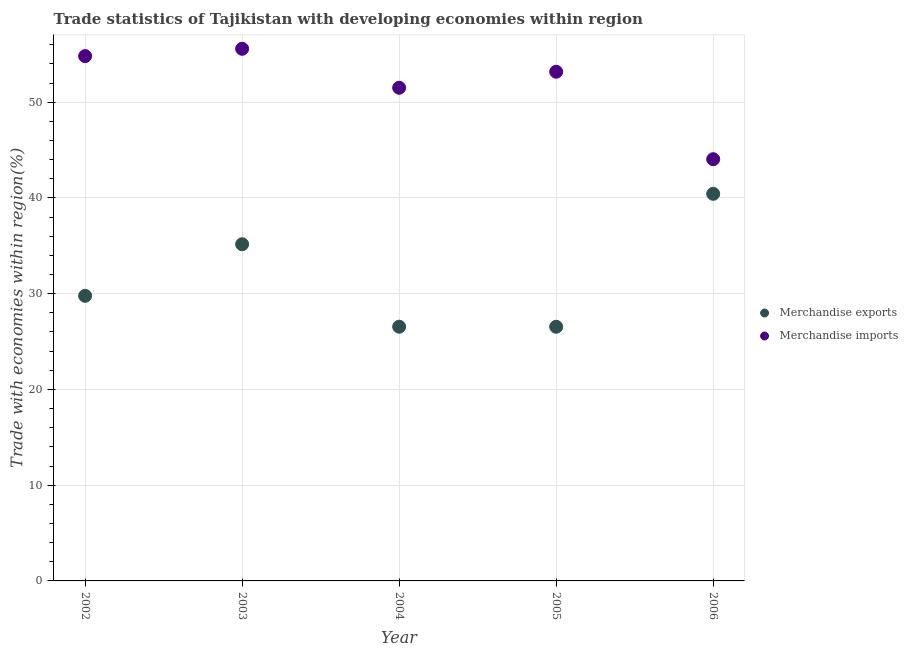How many different coloured dotlines are there?
Make the answer very short. 2. Is the number of dotlines equal to the number of legend labels?
Ensure brevity in your answer.  Yes. What is the merchandise exports in 2003?
Your response must be concise. 35.16. Across all years, what is the maximum merchandise exports?
Make the answer very short. 40.43. Across all years, what is the minimum merchandise exports?
Your response must be concise. 26.54. In which year was the merchandise exports minimum?
Your answer should be very brief. 2005. What is the total merchandise imports in the graph?
Your response must be concise. 259.11. What is the difference between the merchandise imports in 2002 and that in 2003?
Keep it short and to the point. -0.77. What is the difference between the merchandise imports in 2006 and the merchandise exports in 2002?
Make the answer very short. 14.27. What is the average merchandise exports per year?
Offer a terse response. 31.69. In the year 2002, what is the difference between the merchandise imports and merchandise exports?
Offer a terse response. 25.04. What is the ratio of the merchandise exports in 2002 to that in 2003?
Your answer should be very brief. 0.85. Is the difference between the merchandise imports in 2002 and 2005 greater than the difference between the merchandise exports in 2002 and 2005?
Provide a succinct answer. No. What is the difference between the highest and the second highest merchandise imports?
Your response must be concise. 0.77. What is the difference between the highest and the lowest merchandise exports?
Ensure brevity in your answer.  13.88. Is the sum of the merchandise imports in 2003 and 2004 greater than the maximum merchandise exports across all years?
Offer a terse response. Yes. Does the merchandise imports monotonically increase over the years?
Ensure brevity in your answer.  No. How many dotlines are there?
Provide a succinct answer. 2. How many years are there in the graph?
Offer a terse response. 5. Are the values on the major ticks of Y-axis written in scientific E-notation?
Give a very brief answer. No. Does the graph contain any zero values?
Your response must be concise. No. Does the graph contain grids?
Provide a short and direct response. Yes. Where does the legend appear in the graph?
Make the answer very short. Center right. How are the legend labels stacked?
Provide a succinct answer. Vertical. What is the title of the graph?
Your answer should be compact. Trade statistics of Tajikistan with developing economies within region. What is the label or title of the X-axis?
Give a very brief answer. Year. What is the label or title of the Y-axis?
Give a very brief answer. Trade with economies within region(%). What is the Trade with economies within region(%) in Merchandise exports in 2002?
Make the answer very short. 29.77. What is the Trade with economies within region(%) of Merchandise imports in 2002?
Ensure brevity in your answer.  54.81. What is the Trade with economies within region(%) in Merchandise exports in 2003?
Offer a very short reply. 35.16. What is the Trade with economies within region(%) in Merchandise imports in 2003?
Keep it short and to the point. 55.57. What is the Trade with economies within region(%) in Merchandise exports in 2004?
Provide a succinct answer. 26.55. What is the Trade with economies within region(%) in Merchandise imports in 2004?
Your answer should be very brief. 51.5. What is the Trade with economies within region(%) in Merchandise exports in 2005?
Offer a terse response. 26.54. What is the Trade with economies within region(%) of Merchandise imports in 2005?
Provide a short and direct response. 53.18. What is the Trade with economies within region(%) of Merchandise exports in 2006?
Offer a terse response. 40.43. What is the Trade with economies within region(%) in Merchandise imports in 2006?
Your answer should be compact. 44.04. Across all years, what is the maximum Trade with economies within region(%) of Merchandise exports?
Offer a very short reply. 40.43. Across all years, what is the maximum Trade with economies within region(%) of Merchandise imports?
Your answer should be very brief. 55.57. Across all years, what is the minimum Trade with economies within region(%) in Merchandise exports?
Offer a terse response. 26.54. Across all years, what is the minimum Trade with economies within region(%) in Merchandise imports?
Give a very brief answer. 44.04. What is the total Trade with economies within region(%) of Merchandise exports in the graph?
Provide a succinct answer. 158.45. What is the total Trade with economies within region(%) in Merchandise imports in the graph?
Your response must be concise. 259.11. What is the difference between the Trade with economies within region(%) of Merchandise exports in 2002 and that in 2003?
Make the answer very short. -5.39. What is the difference between the Trade with economies within region(%) of Merchandise imports in 2002 and that in 2003?
Offer a very short reply. -0.77. What is the difference between the Trade with economies within region(%) of Merchandise exports in 2002 and that in 2004?
Your answer should be compact. 3.22. What is the difference between the Trade with economies within region(%) in Merchandise imports in 2002 and that in 2004?
Your answer should be compact. 3.3. What is the difference between the Trade with economies within region(%) in Merchandise exports in 2002 and that in 2005?
Make the answer very short. 3.23. What is the difference between the Trade with economies within region(%) in Merchandise imports in 2002 and that in 2005?
Your response must be concise. 1.63. What is the difference between the Trade with economies within region(%) in Merchandise exports in 2002 and that in 2006?
Make the answer very short. -10.65. What is the difference between the Trade with economies within region(%) in Merchandise imports in 2002 and that in 2006?
Provide a succinct answer. 10.77. What is the difference between the Trade with economies within region(%) in Merchandise exports in 2003 and that in 2004?
Offer a terse response. 8.61. What is the difference between the Trade with economies within region(%) in Merchandise imports in 2003 and that in 2004?
Your answer should be compact. 4.07. What is the difference between the Trade with economies within region(%) of Merchandise exports in 2003 and that in 2005?
Give a very brief answer. 8.62. What is the difference between the Trade with economies within region(%) in Merchandise imports in 2003 and that in 2005?
Provide a succinct answer. 2.4. What is the difference between the Trade with economies within region(%) of Merchandise exports in 2003 and that in 2006?
Offer a very short reply. -5.27. What is the difference between the Trade with economies within region(%) of Merchandise imports in 2003 and that in 2006?
Your answer should be very brief. 11.53. What is the difference between the Trade with economies within region(%) of Merchandise exports in 2004 and that in 2005?
Keep it short and to the point. 0.01. What is the difference between the Trade with economies within region(%) of Merchandise imports in 2004 and that in 2005?
Make the answer very short. -1.67. What is the difference between the Trade with economies within region(%) in Merchandise exports in 2004 and that in 2006?
Ensure brevity in your answer.  -13.88. What is the difference between the Trade with economies within region(%) in Merchandise imports in 2004 and that in 2006?
Give a very brief answer. 7.46. What is the difference between the Trade with economies within region(%) of Merchandise exports in 2005 and that in 2006?
Your answer should be very brief. -13.88. What is the difference between the Trade with economies within region(%) in Merchandise imports in 2005 and that in 2006?
Make the answer very short. 9.13. What is the difference between the Trade with economies within region(%) of Merchandise exports in 2002 and the Trade with economies within region(%) of Merchandise imports in 2003?
Make the answer very short. -25.8. What is the difference between the Trade with economies within region(%) of Merchandise exports in 2002 and the Trade with economies within region(%) of Merchandise imports in 2004?
Provide a succinct answer. -21.73. What is the difference between the Trade with economies within region(%) of Merchandise exports in 2002 and the Trade with economies within region(%) of Merchandise imports in 2005?
Keep it short and to the point. -23.4. What is the difference between the Trade with economies within region(%) of Merchandise exports in 2002 and the Trade with economies within region(%) of Merchandise imports in 2006?
Offer a very short reply. -14.27. What is the difference between the Trade with economies within region(%) of Merchandise exports in 2003 and the Trade with economies within region(%) of Merchandise imports in 2004?
Ensure brevity in your answer.  -16.34. What is the difference between the Trade with economies within region(%) in Merchandise exports in 2003 and the Trade with economies within region(%) in Merchandise imports in 2005?
Your answer should be very brief. -18.02. What is the difference between the Trade with economies within region(%) in Merchandise exports in 2003 and the Trade with economies within region(%) in Merchandise imports in 2006?
Give a very brief answer. -8.88. What is the difference between the Trade with economies within region(%) of Merchandise exports in 2004 and the Trade with economies within region(%) of Merchandise imports in 2005?
Your answer should be very brief. -26.63. What is the difference between the Trade with economies within region(%) in Merchandise exports in 2004 and the Trade with economies within region(%) in Merchandise imports in 2006?
Your answer should be very brief. -17.49. What is the difference between the Trade with economies within region(%) in Merchandise exports in 2005 and the Trade with economies within region(%) in Merchandise imports in 2006?
Give a very brief answer. -17.5. What is the average Trade with economies within region(%) of Merchandise exports per year?
Your answer should be compact. 31.69. What is the average Trade with economies within region(%) of Merchandise imports per year?
Keep it short and to the point. 51.82. In the year 2002, what is the difference between the Trade with economies within region(%) in Merchandise exports and Trade with economies within region(%) in Merchandise imports?
Offer a terse response. -25.04. In the year 2003, what is the difference between the Trade with economies within region(%) in Merchandise exports and Trade with economies within region(%) in Merchandise imports?
Offer a terse response. -20.41. In the year 2004, what is the difference between the Trade with economies within region(%) of Merchandise exports and Trade with economies within region(%) of Merchandise imports?
Make the answer very short. -24.96. In the year 2005, what is the difference between the Trade with economies within region(%) of Merchandise exports and Trade with economies within region(%) of Merchandise imports?
Your response must be concise. -26.63. In the year 2006, what is the difference between the Trade with economies within region(%) of Merchandise exports and Trade with economies within region(%) of Merchandise imports?
Give a very brief answer. -3.62. What is the ratio of the Trade with economies within region(%) of Merchandise exports in 2002 to that in 2003?
Make the answer very short. 0.85. What is the ratio of the Trade with economies within region(%) in Merchandise imports in 2002 to that in 2003?
Offer a terse response. 0.99. What is the ratio of the Trade with economies within region(%) of Merchandise exports in 2002 to that in 2004?
Ensure brevity in your answer.  1.12. What is the ratio of the Trade with economies within region(%) in Merchandise imports in 2002 to that in 2004?
Ensure brevity in your answer.  1.06. What is the ratio of the Trade with economies within region(%) in Merchandise exports in 2002 to that in 2005?
Provide a short and direct response. 1.12. What is the ratio of the Trade with economies within region(%) of Merchandise imports in 2002 to that in 2005?
Your response must be concise. 1.03. What is the ratio of the Trade with economies within region(%) in Merchandise exports in 2002 to that in 2006?
Ensure brevity in your answer.  0.74. What is the ratio of the Trade with economies within region(%) of Merchandise imports in 2002 to that in 2006?
Provide a short and direct response. 1.24. What is the ratio of the Trade with economies within region(%) in Merchandise exports in 2003 to that in 2004?
Give a very brief answer. 1.32. What is the ratio of the Trade with economies within region(%) in Merchandise imports in 2003 to that in 2004?
Your response must be concise. 1.08. What is the ratio of the Trade with economies within region(%) in Merchandise exports in 2003 to that in 2005?
Keep it short and to the point. 1.32. What is the ratio of the Trade with economies within region(%) in Merchandise imports in 2003 to that in 2005?
Keep it short and to the point. 1.05. What is the ratio of the Trade with economies within region(%) of Merchandise exports in 2003 to that in 2006?
Give a very brief answer. 0.87. What is the ratio of the Trade with economies within region(%) of Merchandise imports in 2003 to that in 2006?
Make the answer very short. 1.26. What is the ratio of the Trade with economies within region(%) in Merchandise imports in 2004 to that in 2005?
Ensure brevity in your answer.  0.97. What is the ratio of the Trade with economies within region(%) of Merchandise exports in 2004 to that in 2006?
Provide a succinct answer. 0.66. What is the ratio of the Trade with economies within region(%) of Merchandise imports in 2004 to that in 2006?
Offer a terse response. 1.17. What is the ratio of the Trade with economies within region(%) in Merchandise exports in 2005 to that in 2006?
Your answer should be very brief. 0.66. What is the ratio of the Trade with economies within region(%) of Merchandise imports in 2005 to that in 2006?
Your answer should be compact. 1.21. What is the difference between the highest and the second highest Trade with economies within region(%) of Merchandise exports?
Offer a very short reply. 5.27. What is the difference between the highest and the second highest Trade with economies within region(%) in Merchandise imports?
Provide a succinct answer. 0.77. What is the difference between the highest and the lowest Trade with economies within region(%) of Merchandise exports?
Give a very brief answer. 13.88. What is the difference between the highest and the lowest Trade with economies within region(%) of Merchandise imports?
Ensure brevity in your answer.  11.53. 